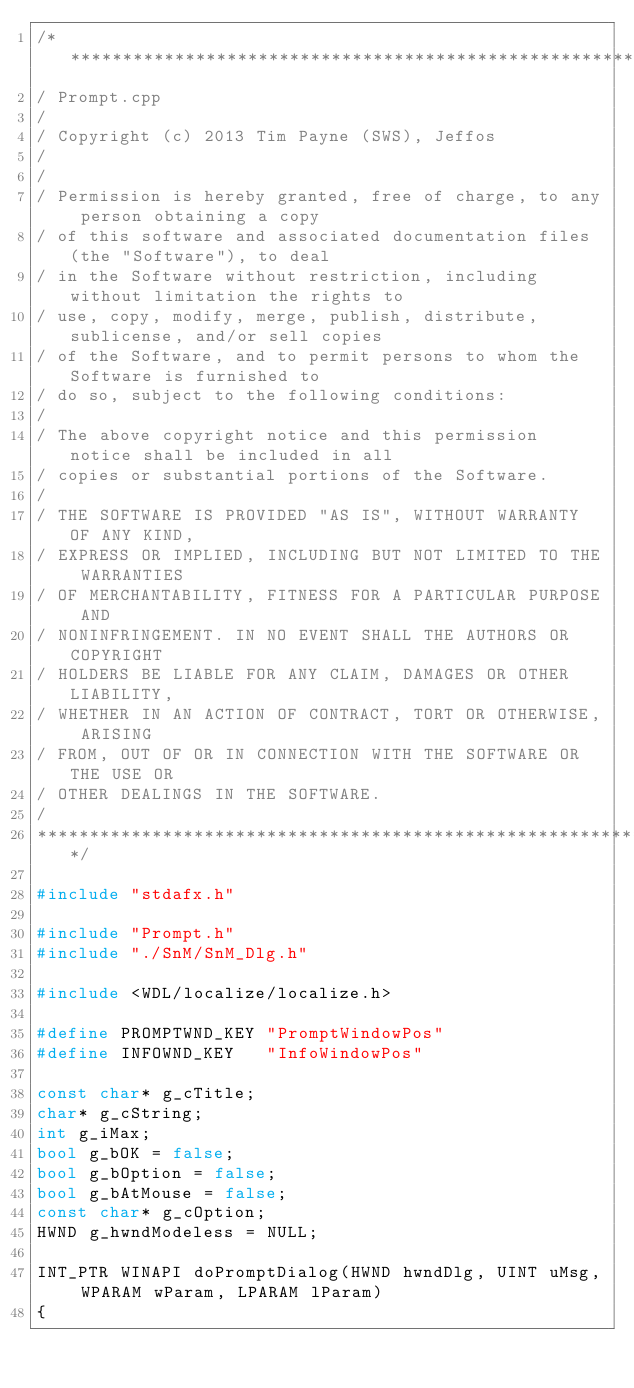<code> <loc_0><loc_0><loc_500><loc_500><_C++_>/******************************************************************************
/ Prompt.cpp
/
/ Copyright (c) 2013 Tim Payne (SWS), Jeffos
/
/
/ Permission is hereby granted, free of charge, to any person obtaining a copy
/ of this software and associated documentation files (the "Software"), to deal
/ in the Software without restriction, including without limitation the rights to
/ use, copy, modify, merge, publish, distribute, sublicense, and/or sell copies
/ of the Software, and to permit persons to whom the Software is furnished to
/ do so, subject to the following conditions:
/ 
/ The above copyright notice and this permission notice shall be included in all
/ copies or substantial portions of the Software.
/ 
/ THE SOFTWARE IS PROVIDED "AS IS", WITHOUT WARRANTY OF ANY KIND,
/ EXPRESS OR IMPLIED, INCLUDING BUT NOT LIMITED TO THE WARRANTIES
/ OF MERCHANTABILITY, FITNESS FOR A PARTICULAR PURPOSE AND
/ NONINFRINGEMENT. IN NO EVENT SHALL THE AUTHORS OR COPYRIGHT
/ HOLDERS BE LIABLE FOR ANY CLAIM, DAMAGES OR OTHER LIABILITY,
/ WHETHER IN AN ACTION OF CONTRACT, TORT OR OTHERWISE, ARISING
/ FROM, OUT OF OR IN CONNECTION WITH THE SOFTWARE OR THE USE OR
/ OTHER DEALINGS IN THE SOFTWARE.
/
******************************************************************************/

#include "stdafx.h"

#include "Prompt.h"
#include "./SnM/SnM_Dlg.h"

#include <WDL/localize/localize.h>

#define PROMPTWND_KEY	"PromptWindowPos"
#define INFOWND_KEY		"InfoWindowPos"

const char* g_cTitle;
char* g_cString;
int g_iMax;
bool g_bOK = false;
bool g_bOption = false;
bool g_bAtMouse = false;
const char* g_cOption;
HWND g_hwndModeless = NULL;

INT_PTR WINAPI doPromptDialog(HWND hwndDlg, UINT uMsg, WPARAM wParam, LPARAM lParam)
{</code> 